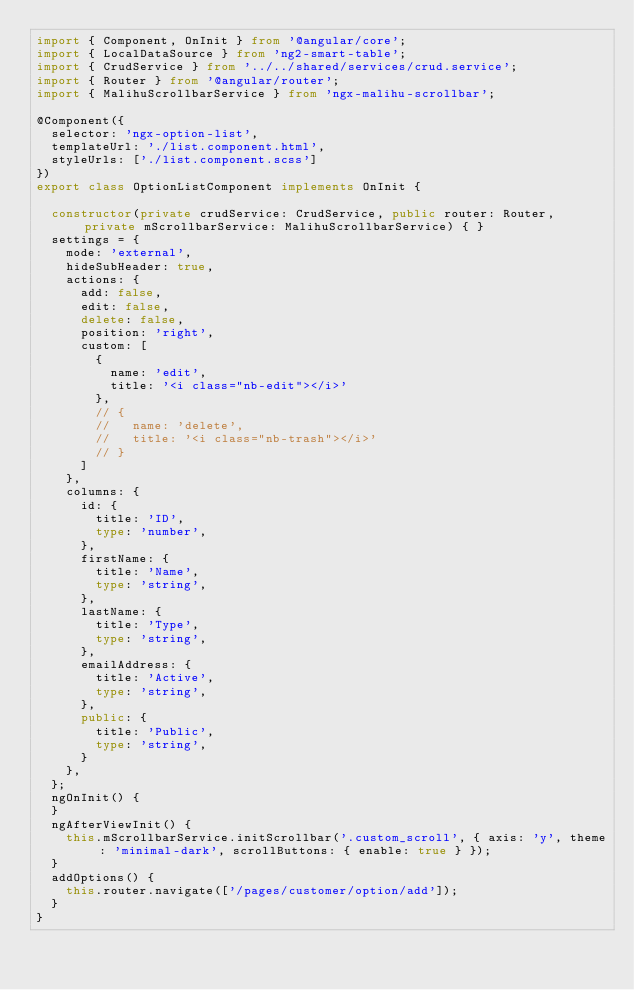<code> <loc_0><loc_0><loc_500><loc_500><_TypeScript_>import { Component, OnInit } from '@angular/core';
import { LocalDataSource } from 'ng2-smart-table';
import { CrudService } from '../../shared/services/crud.service';
import { Router } from '@angular/router';
import { MalihuScrollbarService } from 'ngx-malihu-scrollbar';

@Component({
  selector: 'ngx-option-list',
  templateUrl: './list.component.html',
  styleUrls: ['./list.component.scss']
})
export class OptionListComponent implements OnInit {

  constructor(private crudService: CrudService, public router: Router, private mScrollbarService: MalihuScrollbarService) { }
  settings = {
    mode: 'external',
    hideSubHeader: true,
    actions: {
      add: false,
      edit: false,
      delete: false,
      position: 'right',
      custom: [
        {
          name: 'edit',
          title: '<i class="nb-edit"></i>'
        },
        // {
        //   name: 'delete',
        //   title: '<i class="nb-trash"></i>'
        // }
      ]
    },
    columns: {
      id: {
        title: 'ID',
        type: 'number',
      },
      firstName: {
        title: 'Name',
        type: 'string',
      },
      lastName: {
        title: 'Type',
        type: 'string',
      },
      emailAddress: {
        title: 'Active',
        type: 'string',
      },
      public: {
        title: 'Public',
        type: 'string',
      }
    },
  };
  ngOnInit() {
  }
  ngAfterViewInit() {
    this.mScrollbarService.initScrollbar('.custom_scroll', { axis: 'y', theme: 'minimal-dark', scrollButtons: { enable: true } });
  }
  addOptions() {
    this.router.navigate(['/pages/customer/option/add']);
  }
}
</code> 